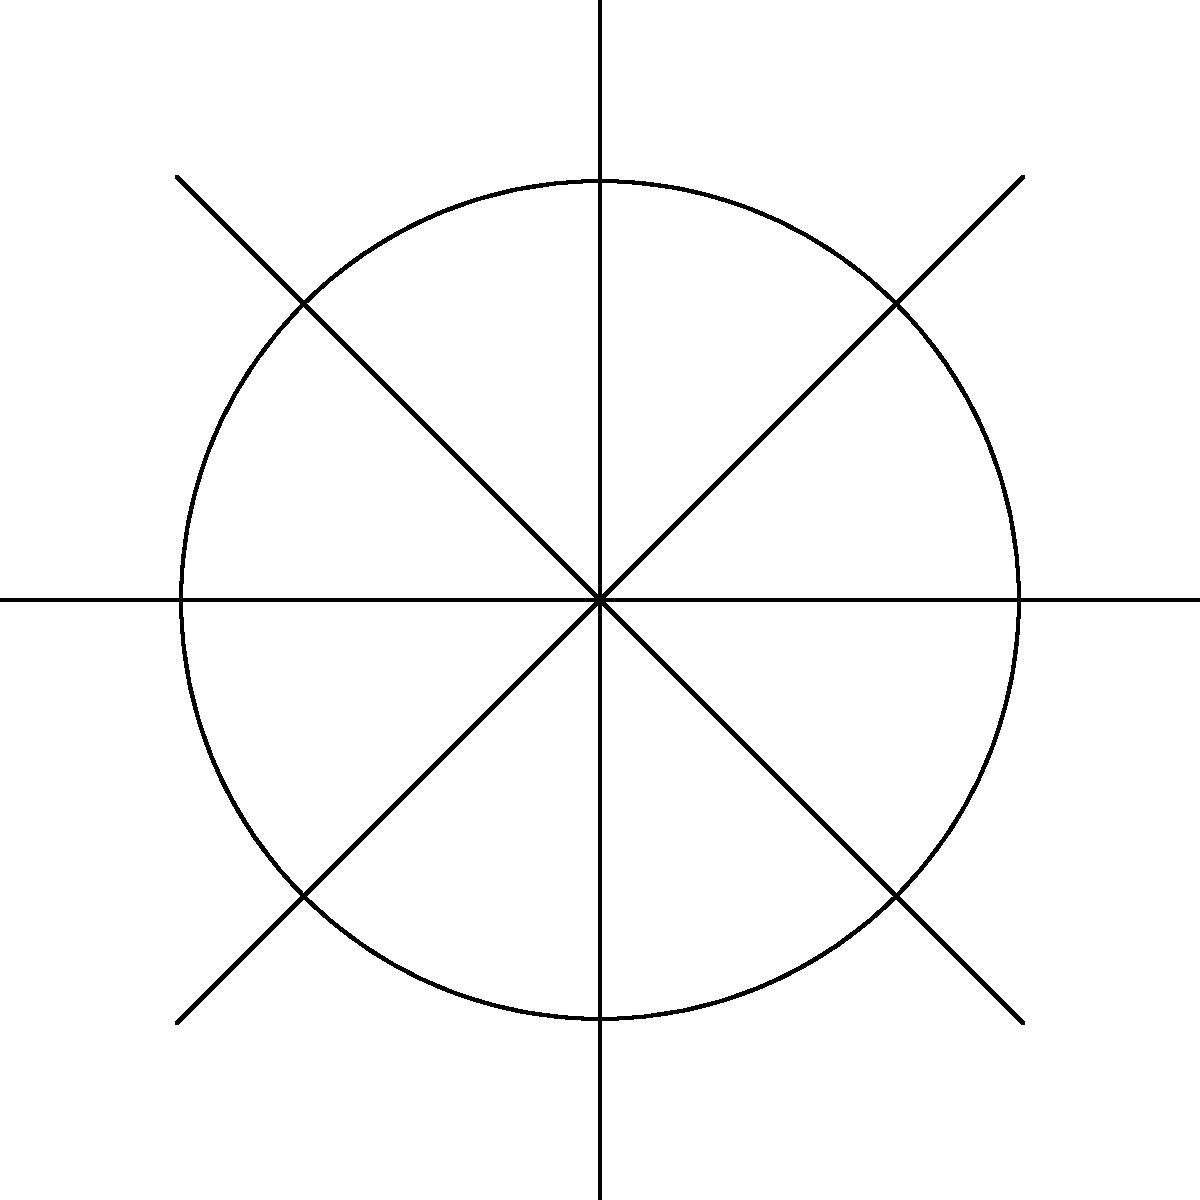In this stylized daisy design, how many pairs of congruent petals can be formed? To determine the number of pairs of congruent petals, let's follow these steps:

1. Count the total number of petals in the daisy design:
   There are 8 petals in total.

2. Understand the concept of congruence in this context:
   Congruent petals are identical in shape and size, differing only in their position.

3. Analyze the symmetry of the design:
   The daisy is perfectly symmetrical, with all petals identical in shape and size.

4. Calculate the number of possible pairs:
   - Each petal can form a pair with any other petal.
   - The number of pairs is given by the combination formula: $\binom{n}{2} = \frac{n!}{2!(n-2)!}$
   - Where $n$ is the total number of petals (8 in this case).

5. Apply the formula:
   $\binom{8}{2} = \frac{8!}{2!(8-2)!} = \frac{8 \cdot 7}{2} = 28$

Therefore, 28 pairs of congruent petals can be formed from this daisy design.
Answer: 28 pairs 